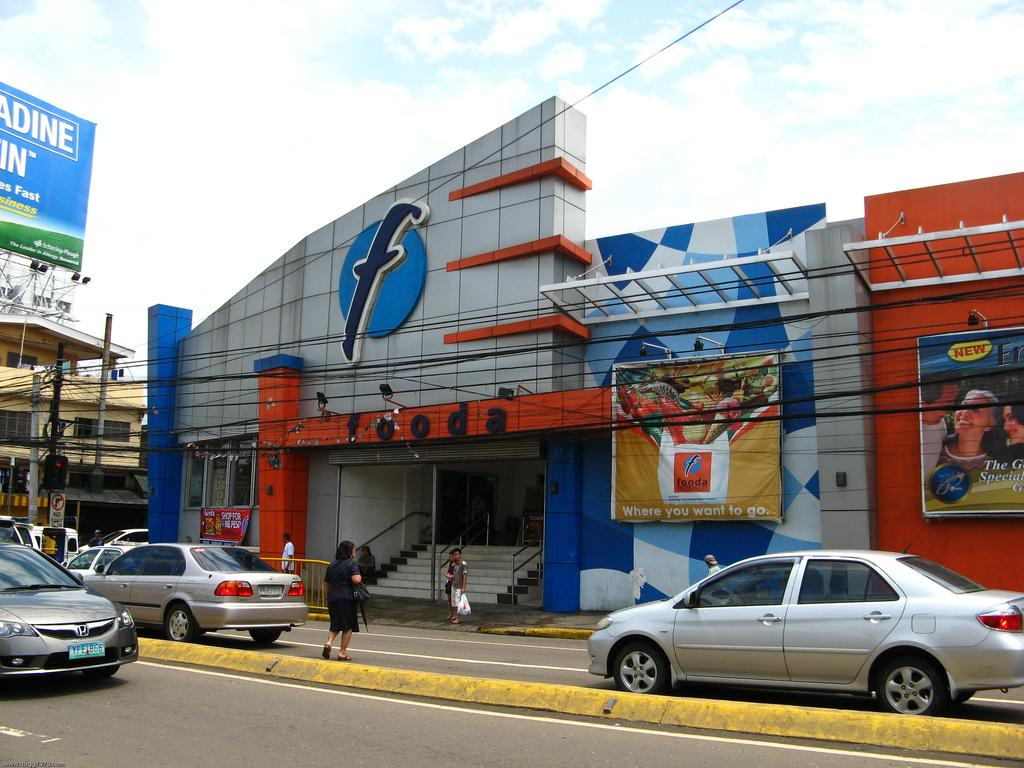<image>
Describe the image concisely. A store with a large F on the front has cars passing by. 